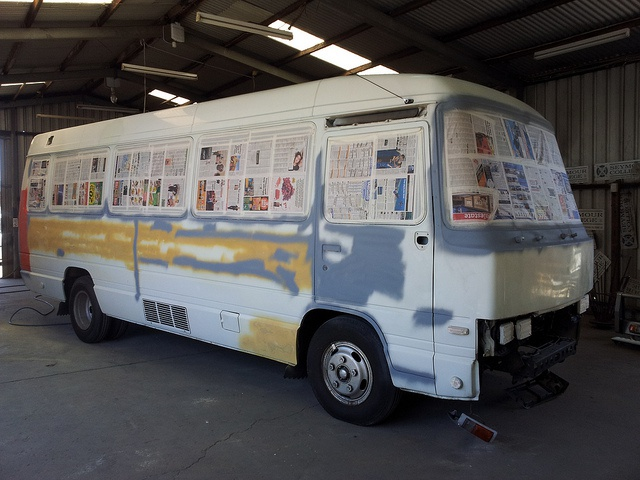Describe the objects in this image and their specific colors. I can see bus in white, darkgray, gray, and black tones in this image. 